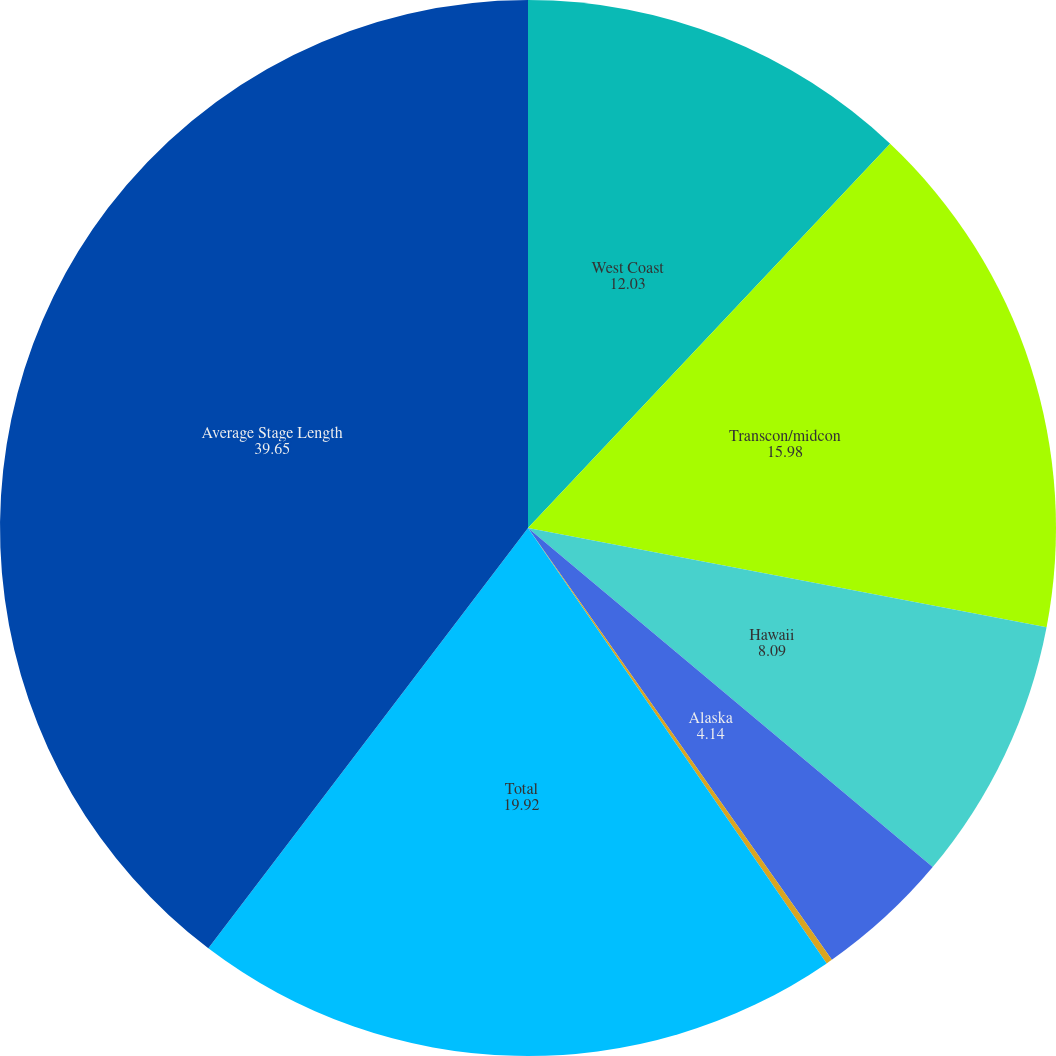Convert chart to OTSL. <chart><loc_0><loc_0><loc_500><loc_500><pie_chart><fcel>West Coast<fcel>Transcon/midcon<fcel>Hawaii<fcel>Alaska<fcel>Mexico<fcel>Total<fcel>Average Stage Length<nl><fcel>12.03%<fcel>15.98%<fcel>8.09%<fcel>4.14%<fcel>0.19%<fcel>19.92%<fcel>39.65%<nl></chart> 